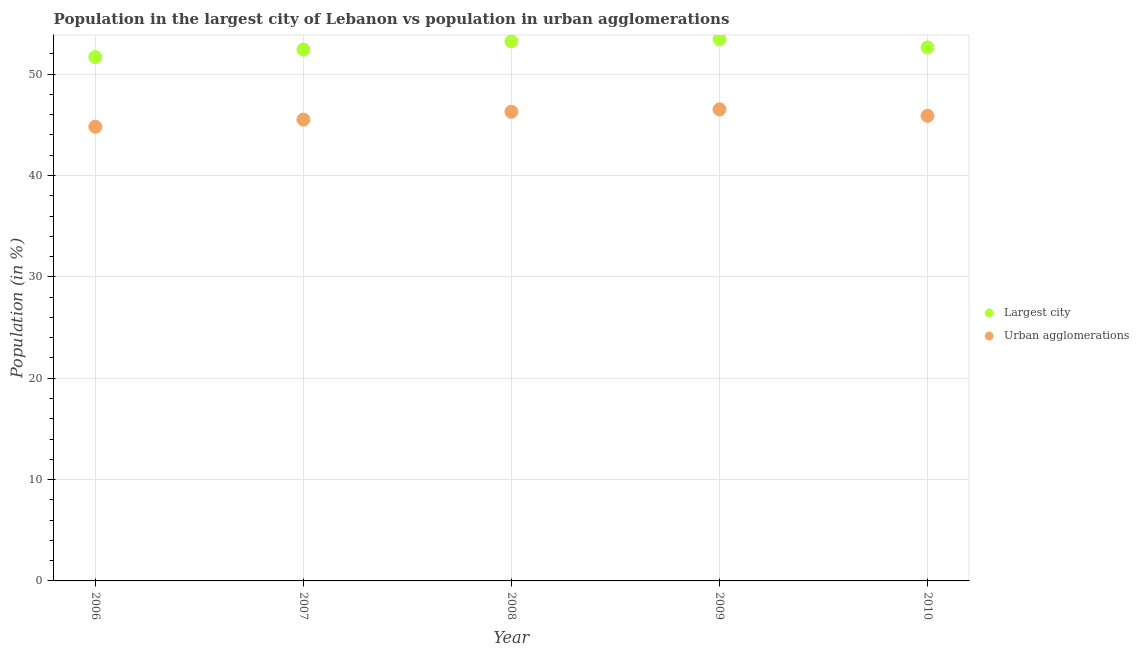How many different coloured dotlines are there?
Give a very brief answer. 2. Is the number of dotlines equal to the number of legend labels?
Offer a very short reply. Yes. What is the population in urban agglomerations in 2008?
Offer a very short reply. 46.29. Across all years, what is the maximum population in the largest city?
Your answer should be compact. 53.44. Across all years, what is the minimum population in urban agglomerations?
Keep it short and to the point. 44.81. In which year was the population in the largest city maximum?
Ensure brevity in your answer.  2009. In which year was the population in urban agglomerations minimum?
Provide a succinct answer. 2006. What is the total population in the largest city in the graph?
Ensure brevity in your answer.  263.43. What is the difference between the population in the largest city in 2007 and that in 2009?
Offer a very short reply. -1.02. What is the difference between the population in the largest city in 2010 and the population in urban agglomerations in 2009?
Offer a very short reply. 6.11. What is the average population in the largest city per year?
Your answer should be very brief. 52.69. In the year 2007, what is the difference between the population in the largest city and population in urban agglomerations?
Make the answer very short. 6.91. What is the ratio of the population in urban agglomerations in 2007 to that in 2008?
Your answer should be compact. 0.98. What is the difference between the highest and the second highest population in urban agglomerations?
Ensure brevity in your answer.  0.24. What is the difference between the highest and the lowest population in urban agglomerations?
Offer a terse response. 1.72. In how many years, is the population in the largest city greater than the average population in the largest city taken over all years?
Keep it short and to the point. 2. Is the sum of the population in urban agglomerations in 2007 and 2009 greater than the maximum population in the largest city across all years?
Your answer should be very brief. Yes. Does the population in urban agglomerations monotonically increase over the years?
Give a very brief answer. No. Is the population in urban agglomerations strictly greater than the population in the largest city over the years?
Offer a very short reply. No. How many dotlines are there?
Provide a succinct answer. 2. How many years are there in the graph?
Provide a succinct answer. 5. Are the values on the major ticks of Y-axis written in scientific E-notation?
Your response must be concise. No. Where does the legend appear in the graph?
Ensure brevity in your answer.  Center right. How many legend labels are there?
Offer a terse response. 2. How are the legend labels stacked?
Make the answer very short. Vertical. What is the title of the graph?
Offer a terse response. Population in the largest city of Lebanon vs population in urban agglomerations. Does "Forest land" appear as one of the legend labels in the graph?
Your answer should be very brief. No. What is the label or title of the X-axis?
Your response must be concise. Year. What is the Population (in %) in Largest city in 2006?
Keep it short and to the point. 51.68. What is the Population (in %) in Urban agglomerations in 2006?
Your response must be concise. 44.81. What is the Population (in %) in Largest city in 2007?
Your response must be concise. 52.43. What is the Population (in %) in Urban agglomerations in 2007?
Offer a terse response. 45.52. What is the Population (in %) of Largest city in 2008?
Your answer should be very brief. 53.24. What is the Population (in %) in Urban agglomerations in 2008?
Offer a very short reply. 46.29. What is the Population (in %) in Largest city in 2009?
Keep it short and to the point. 53.44. What is the Population (in %) of Urban agglomerations in 2009?
Provide a short and direct response. 46.53. What is the Population (in %) of Largest city in 2010?
Your answer should be compact. 52.63. What is the Population (in %) in Urban agglomerations in 2010?
Your response must be concise. 45.89. Across all years, what is the maximum Population (in %) in Largest city?
Offer a terse response. 53.44. Across all years, what is the maximum Population (in %) in Urban agglomerations?
Offer a terse response. 46.53. Across all years, what is the minimum Population (in %) of Largest city?
Keep it short and to the point. 51.68. Across all years, what is the minimum Population (in %) of Urban agglomerations?
Your answer should be very brief. 44.81. What is the total Population (in %) in Largest city in the graph?
Your answer should be compact. 263.43. What is the total Population (in %) of Urban agglomerations in the graph?
Make the answer very short. 229.04. What is the difference between the Population (in %) of Largest city in 2006 and that in 2007?
Provide a short and direct response. -0.74. What is the difference between the Population (in %) of Urban agglomerations in 2006 and that in 2007?
Offer a very short reply. -0.71. What is the difference between the Population (in %) of Largest city in 2006 and that in 2008?
Offer a terse response. -1.56. What is the difference between the Population (in %) of Urban agglomerations in 2006 and that in 2008?
Provide a succinct answer. -1.48. What is the difference between the Population (in %) in Largest city in 2006 and that in 2009?
Ensure brevity in your answer.  -1.76. What is the difference between the Population (in %) of Urban agglomerations in 2006 and that in 2009?
Give a very brief answer. -1.72. What is the difference between the Population (in %) of Largest city in 2006 and that in 2010?
Make the answer very short. -0.95. What is the difference between the Population (in %) in Urban agglomerations in 2006 and that in 2010?
Your answer should be very brief. -1.08. What is the difference between the Population (in %) in Largest city in 2007 and that in 2008?
Your answer should be very brief. -0.81. What is the difference between the Population (in %) of Urban agglomerations in 2007 and that in 2008?
Your answer should be compact. -0.77. What is the difference between the Population (in %) in Largest city in 2007 and that in 2009?
Provide a short and direct response. -1.02. What is the difference between the Population (in %) in Urban agglomerations in 2007 and that in 2009?
Make the answer very short. -1.01. What is the difference between the Population (in %) of Largest city in 2007 and that in 2010?
Your answer should be compact. -0.21. What is the difference between the Population (in %) of Urban agglomerations in 2007 and that in 2010?
Ensure brevity in your answer.  -0.37. What is the difference between the Population (in %) of Largest city in 2008 and that in 2009?
Keep it short and to the point. -0.2. What is the difference between the Population (in %) in Urban agglomerations in 2008 and that in 2009?
Offer a very short reply. -0.24. What is the difference between the Population (in %) of Largest city in 2008 and that in 2010?
Offer a very short reply. 0.61. What is the difference between the Population (in %) in Urban agglomerations in 2008 and that in 2010?
Your response must be concise. 0.4. What is the difference between the Population (in %) of Largest city in 2009 and that in 2010?
Keep it short and to the point. 0.81. What is the difference between the Population (in %) of Urban agglomerations in 2009 and that in 2010?
Provide a short and direct response. 0.64. What is the difference between the Population (in %) in Largest city in 2006 and the Population (in %) in Urban agglomerations in 2007?
Keep it short and to the point. 6.17. What is the difference between the Population (in %) in Largest city in 2006 and the Population (in %) in Urban agglomerations in 2008?
Offer a terse response. 5.39. What is the difference between the Population (in %) of Largest city in 2006 and the Population (in %) of Urban agglomerations in 2009?
Offer a terse response. 5.15. What is the difference between the Population (in %) in Largest city in 2006 and the Population (in %) in Urban agglomerations in 2010?
Make the answer very short. 5.79. What is the difference between the Population (in %) of Largest city in 2007 and the Population (in %) of Urban agglomerations in 2008?
Give a very brief answer. 6.14. What is the difference between the Population (in %) in Largest city in 2007 and the Population (in %) in Urban agglomerations in 2009?
Offer a terse response. 5.9. What is the difference between the Population (in %) of Largest city in 2007 and the Population (in %) of Urban agglomerations in 2010?
Your answer should be very brief. 6.54. What is the difference between the Population (in %) of Largest city in 2008 and the Population (in %) of Urban agglomerations in 2009?
Give a very brief answer. 6.71. What is the difference between the Population (in %) in Largest city in 2008 and the Population (in %) in Urban agglomerations in 2010?
Give a very brief answer. 7.35. What is the difference between the Population (in %) of Largest city in 2009 and the Population (in %) of Urban agglomerations in 2010?
Make the answer very short. 7.55. What is the average Population (in %) of Largest city per year?
Make the answer very short. 52.69. What is the average Population (in %) of Urban agglomerations per year?
Offer a very short reply. 45.81. In the year 2006, what is the difference between the Population (in %) in Largest city and Population (in %) in Urban agglomerations?
Keep it short and to the point. 6.87. In the year 2007, what is the difference between the Population (in %) of Largest city and Population (in %) of Urban agglomerations?
Keep it short and to the point. 6.91. In the year 2008, what is the difference between the Population (in %) of Largest city and Population (in %) of Urban agglomerations?
Ensure brevity in your answer.  6.95. In the year 2009, what is the difference between the Population (in %) in Largest city and Population (in %) in Urban agglomerations?
Your response must be concise. 6.91. In the year 2010, what is the difference between the Population (in %) in Largest city and Population (in %) in Urban agglomerations?
Your response must be concise. 6.75. What is the ratio of the Population (in %) of Largest city in 2006 to that in 2007?
Make the answer very short. 0.99. What is the ratio of the Population (in %) in Urban agglomerations in 2006 to that in 2007?
Keep it short and to the point. 0.98. What is the ratio of the Population (in %) in Largest city in 2006 to that in 2008?
Provide a succinct answer. 0.97. What is the ratio of the Population (in %) of Urban agglomerations in 2006 to that in 2008?
Ensure brevity in your answer.  0.97. What is the ratio of the Population (in %) in Largest city in 2006 to that in 2009?
Offer a very short reply. 0.97. What is the ratio of the Population (in %) of Urban agglomerations in 2006 to that in 2009?
Make the answer very short. 0.96. What is the ratio of the Population (in %) of Largest city in 2006 to that in 2010?
Provide a succinct answer. 0.98. What is the ratio of the Population (in %) of Urban agglomerations in 2006 to that in 2010?
Keep it short and to the point. 0.98. What is the ratio of the Population (in %) of Largest city in 2007 to that in 2008?
Your response must be concise. 0.98. What is the ratio of the Population (in %) in Urban agglomerations in 2007 to that in 2008?
Offer a terse response. 0.98. What is the ratio of the Population (in %) in Urban agglomerations in 2007 to that in 2009?
Provide a succinct answer. 0.98. What is the ratio of the Population (in %) of Largest city in 2007 to that in 2010?
Keep it short and to the point. 1. What is the ratio of the Population (in %) in Urban agglomerations in 2007 to that in 2010?
Keep it short and to the point. 0.99. What is the ratio of the Population (in %) in Largest city in 2008 to that in 2009?
Provide a short and direct response. 1. What is the ratio of the Population (in %) of Largest city in 2008 to that in 2010?
Provide a short and direct response. 1.01. What is the ratio of the Population (in %) in Urban agglomerations in 2008 to that in 2010?
Ensure brevity in your answer.  1.01. What is the ratio of the Population (in %) of Largest city in 2009 to that in 2010?
Ensure brevity in your answer.  1.02. What is the difference between the highest and the second highest Population (in %) in Largest city?
Ensure brevity in your answer.  0.2. What is the difference between the highest and the second highest Population (in %) of Urban agglomerations?
Ensure brevity in your answer.  0.24. What is the difference between the highest and the lowest Population (in %) in Largest city?
Offer a terse response. 1.76. What is the difference between the highest and the lowest Population (in %) of Urban agglomerations?
Offer a terse response. 1.72. 